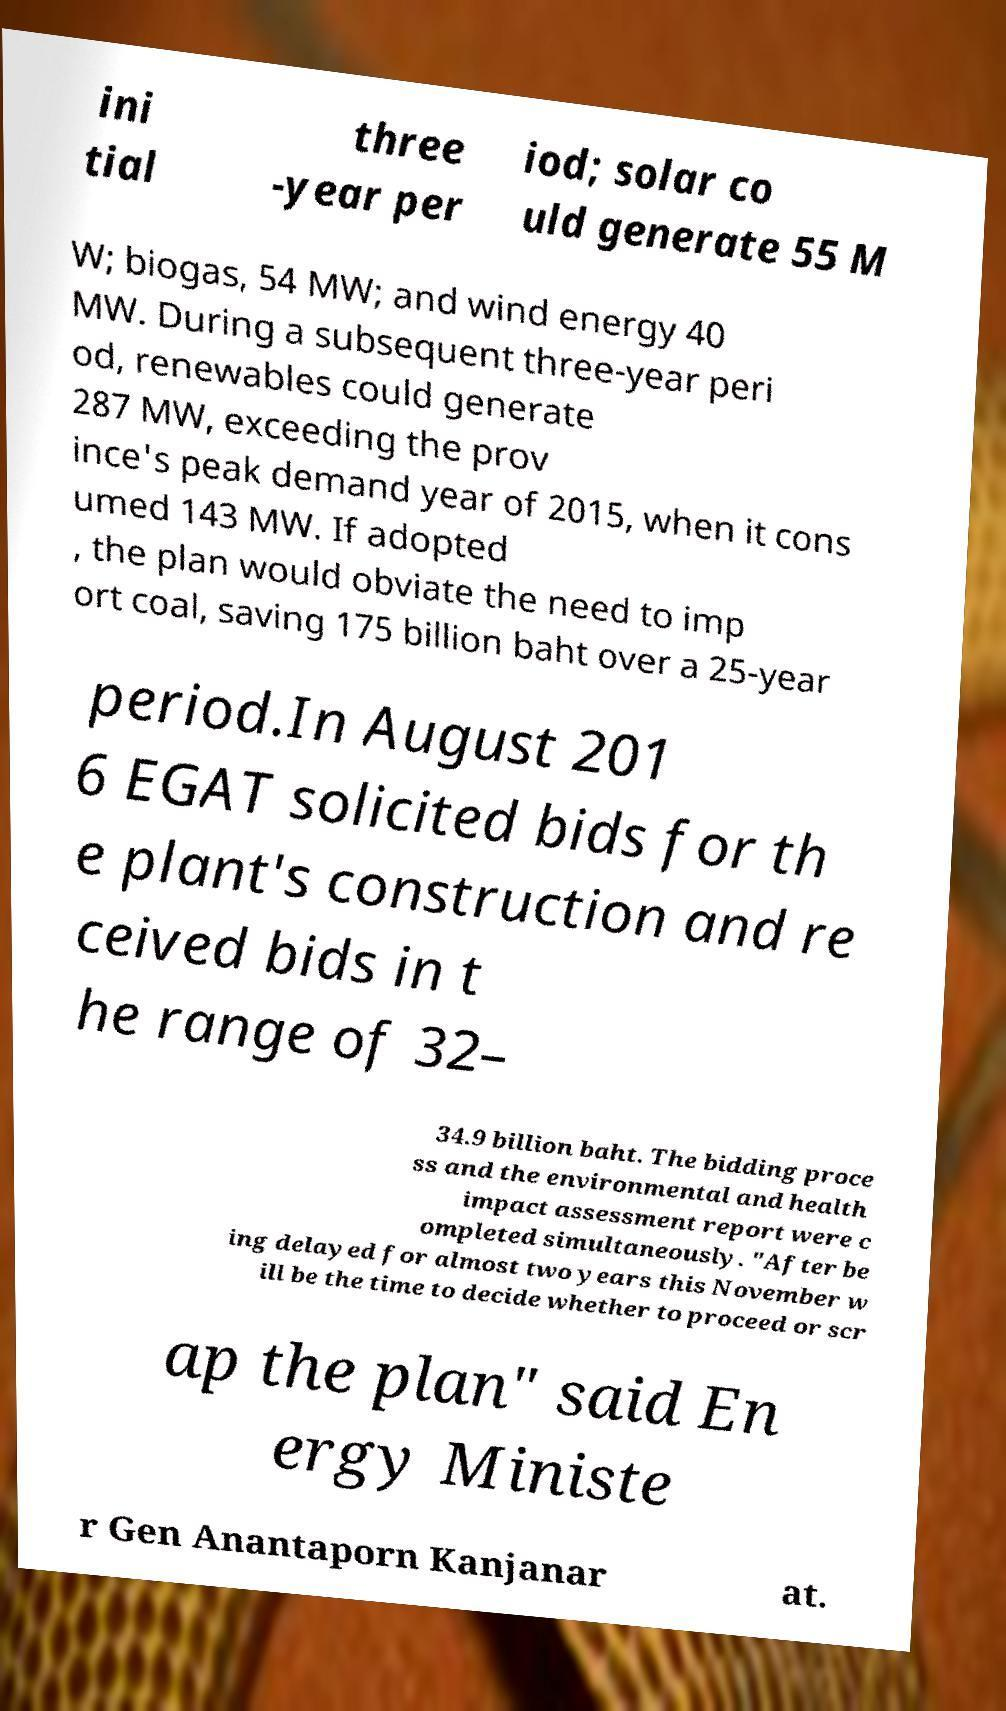Please identify and transcribe the text found in this image. ini tial three -year per iod; solar co uld generate 55 M W; biogas, 54 MW; and wind energy 40 MW. During a subsequent three-year peri od, renewables could generate 287 MW, exceeding the prov ince's peak demand year of 2015, when it cons umed 143 MW. If adopted , the plan would obviate the need to imp ort coal, saving 175 billion baht over a 25-year period.In August 201 6 EGAT solicited bids for th e plant's construction and re ceived bids in t he range of 32– 34.9 billion baht. The bidding proce ss and the environmental and health impact assessment report were c ompleted simultaneously. "After be ing delayed for almost two years this November w ill be the time to decide whether to proceed or scr ap the plan" said En ergy Ministe r Gen Anantaporn Kanjanar at. 